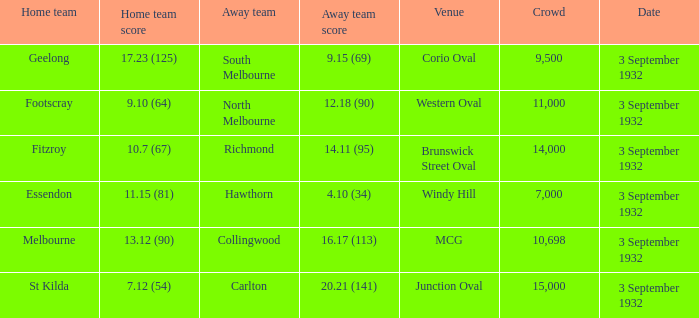How many people are in the crowd for the team that has scored 12.18 (90) as the away team? 11000.0. 